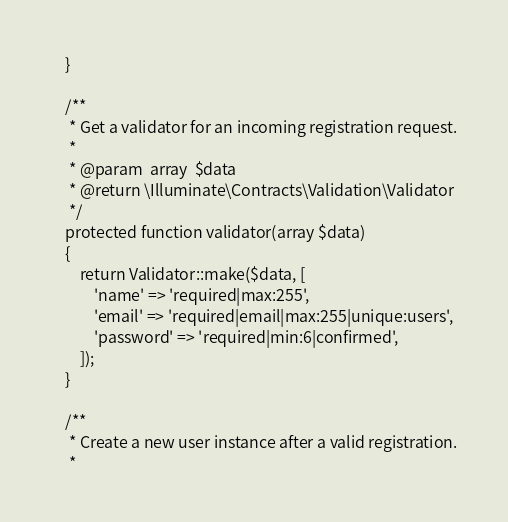<code> <loc_0><loc_0><loc_500><loc_500><_PHP_>    }

    /**
     * Get a validator for an incoming registration request.
     *
     * @param  array  $data
     * @return \Illuminate\Contracts\Validation\Validator
     */
    protected function validator(array $data)
    {
        return Validator::make($data, [
            'name' => 'required|max:255',
            'email' => 'required|email|max:255|unique:users',
            'password' => 'required|min:6|confirmed',
        ]);
    }

    /**
     * Create a new user instance after a valid registration.
     *</code> 